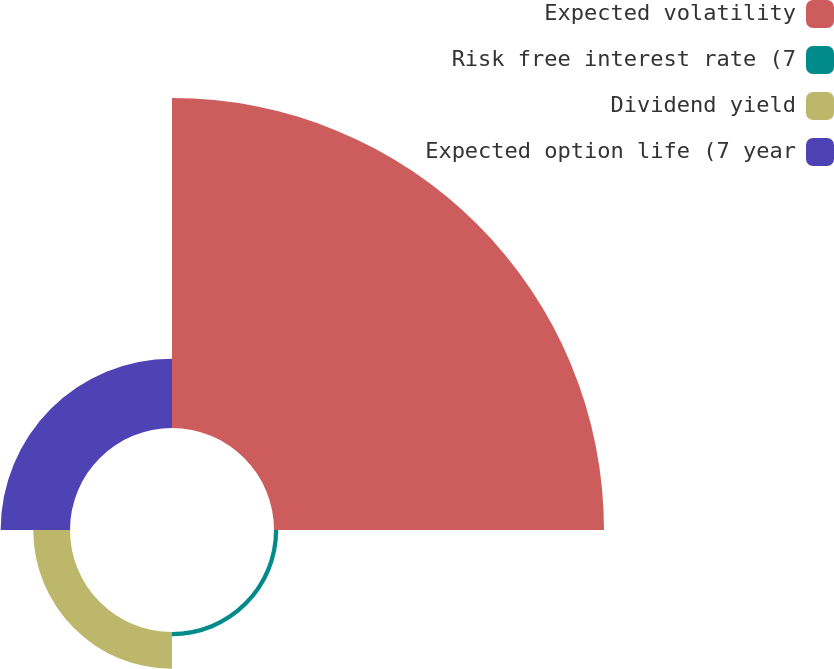Convert chart to OTSL. <chart><loc_0><loc_0><loc_500><loc_500><pie_chart><fcel>Expected volatility<fcel>Risk free interest rate (7<fcel>Dividend yield<fcel>Expected option life (7 year<nl><fcel>74.94%<fcel>0.96%<fcel>8.35%<fcel>15.75%<nl></chart> 